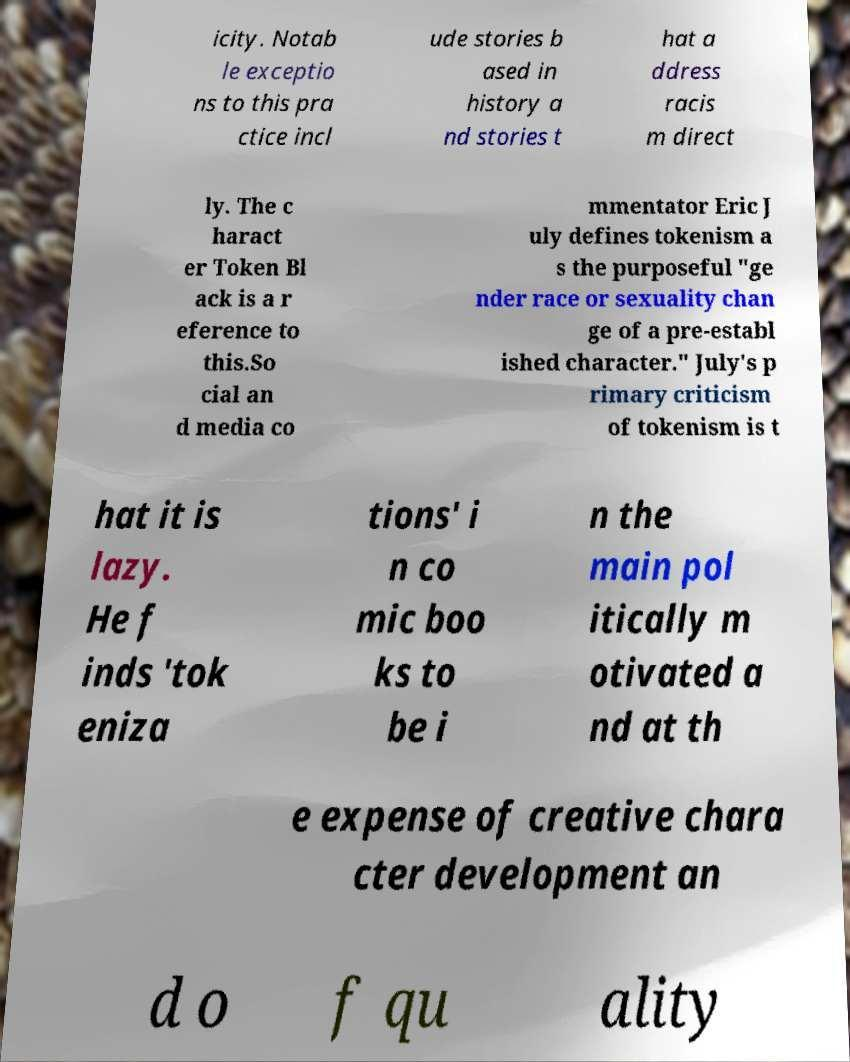I need the written content from this picture converted into text. Can you do that? icity. Notab le exceptio ns to this pra ctice incl ude stories b ased in history a nd stories t hat a ddress racis m direct ly. The c haract er Token Bl ack is a r eference to this.So cial an d media co mmentator Eric J uly defines tokenism a s the purposeful "ge nder race or sexuality chan ge of a pre-establ ished character." July's p rimary criticism of tokenism is t hat it is lazy. He f inds 'tok eniza tions' i n co mic boo ks to be i n the main pol itically m otivated a nd at th e expense of creative chara cter development an d o f qu ality 